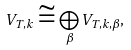<formula> <loc_0><loc_0><loc_500><loc_500>V _ { T , k } \cong \bigoplus _ { \beta } V _ { T , k , \beta } ,</formula> 